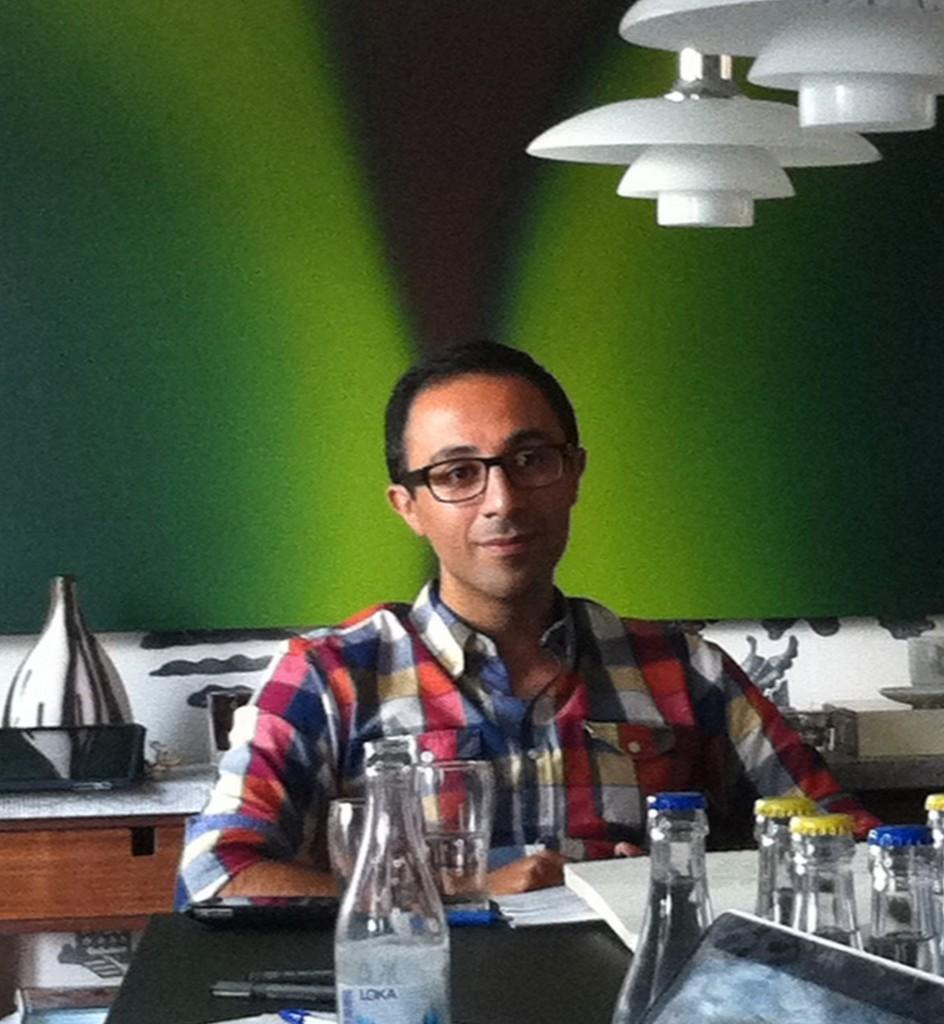What is the man in the image doing? The man is sitting on a chair in the image. What objects are in front of the man? There are bottles and a glass in front of the man. What color is the background in the image? The background is green. How does the man interact with the wave in the image? There is no wave present in the image; the man is sitting on a chair with bottles and a glass in front of him. 